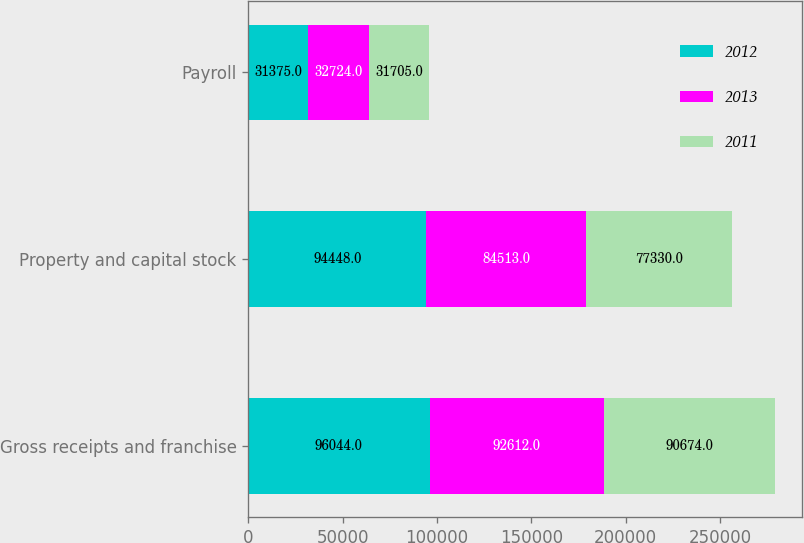<chart> <loc_0><loc_0><loc_500><loc_500><stacked_bar_chart><ecel><fcel>Gross receipts and franchise<fcel>Property and capital stock<fcel>Payroll<nl><fcel>2012<fcel>96044<fcel>94448<fcel>31375<nl><fcel>2013<fcel>92612<fcel>84513<fcel>32724<nl><fcel>2011<fcel>90674<fcel>77330<fcel>31705<nl></chart> 